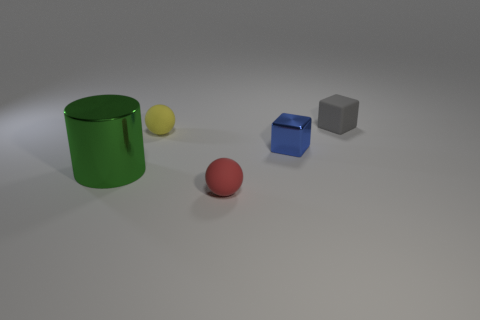Add 4 blue blocks. How many objects exist? 9 Subtract all cylinders. How many objects are left? 4 Subtract all green metallic things. Subtract all shiny cylinders. How many objects are left? 3 Add 4 balls. How many balls are left? 6 Add 2 tiny balls. How many tiny balls exist? 4 Subtract 0 green cubes. How many objects are left? 5 